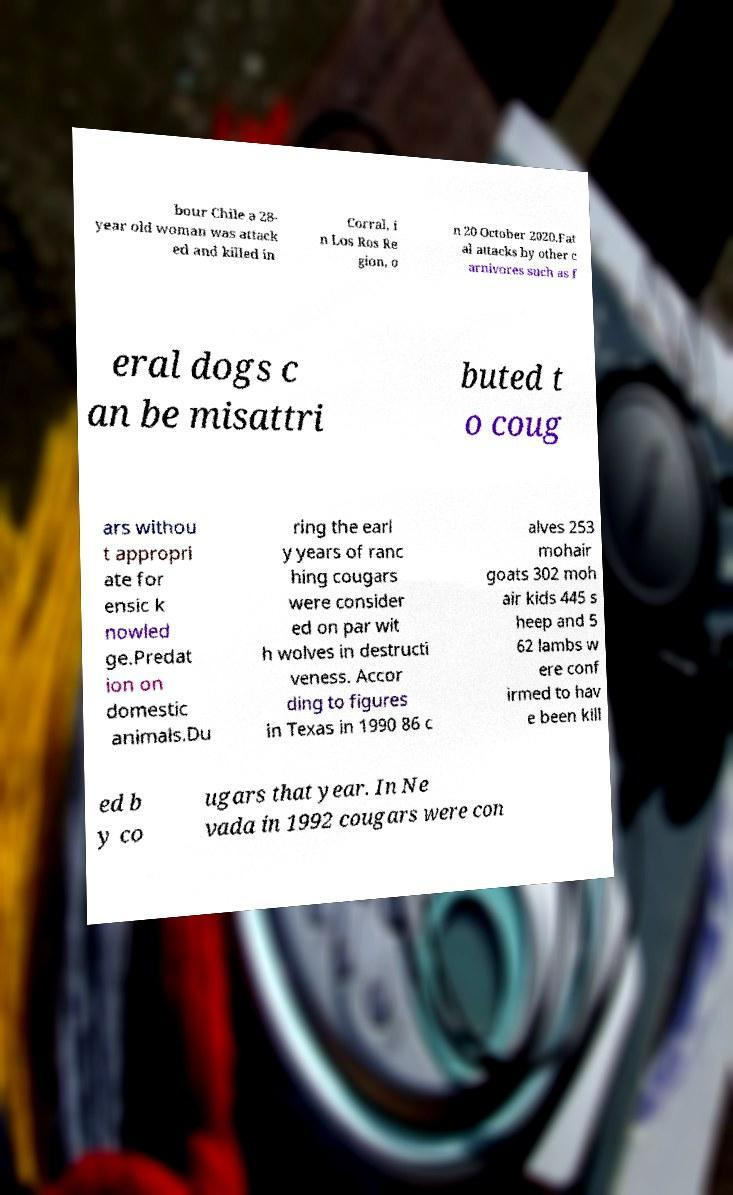There's text embedded in this image that I need extracted. Can you transcribe it verbatim? bour Chile a 28- year old woman was attack ed and killed in Corral, i n Los Ros Re gion, o n 20 October 2020.Fat al attacks by other c arnivores such as f eral dogs c an be misattri buted t o coug ars withou t appropri ate for ensic k nowled ge.Predat ion on domestic animals.Du ring the earl y years of ranc hing cougars were consider ed on par wit h wolves in destructi veness. Accor ding to figures in Texas in 1990 86 c alves 253 mohair goats 302 moh air kids 445 s heep and 5 62 lambs w ere conf irmed to hav e been kill ed b y co ugars that year. In Ne vada in 1992 cougars were con 